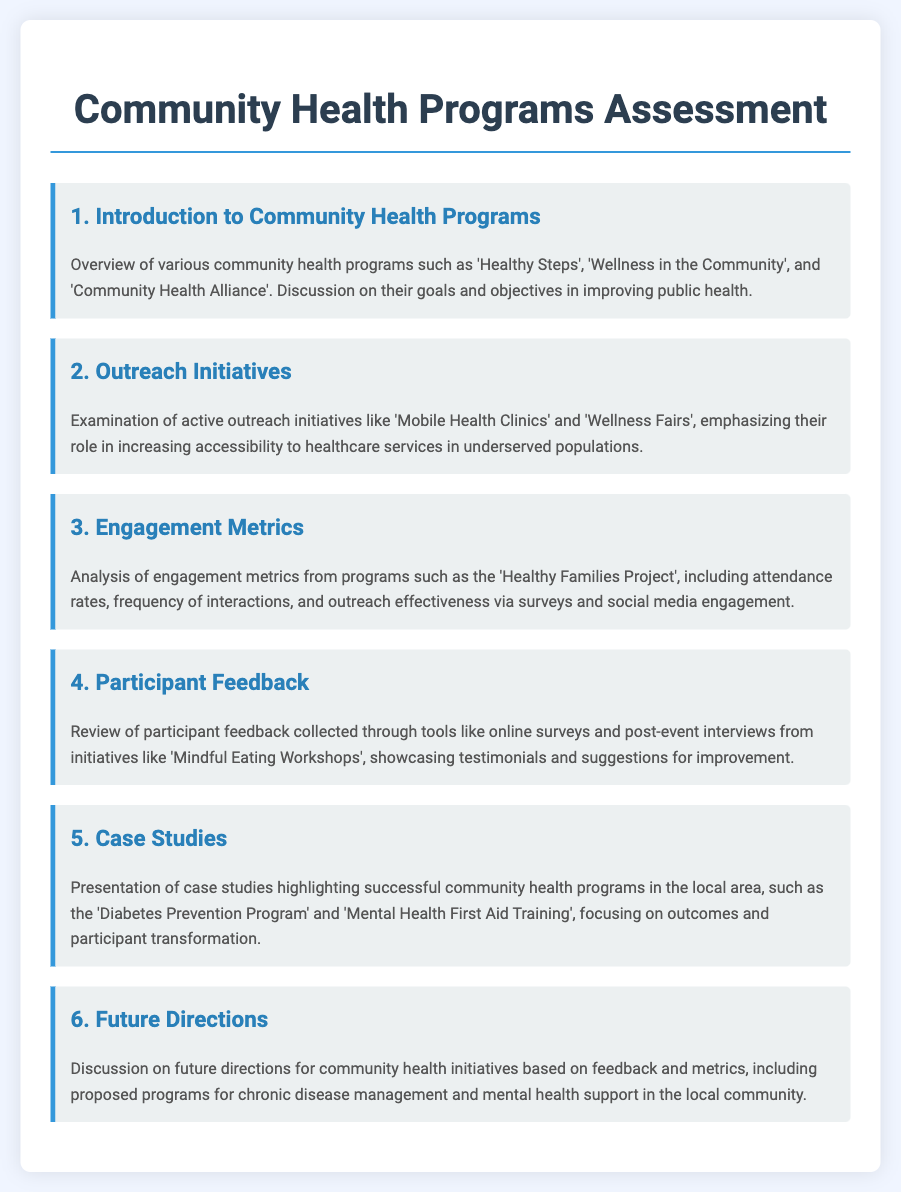what is the title of the document? The title of the document is provided in the header section, indicating the main topic discussed.
Answer: Community Health Programs Assessment how many community health programs are mentioned? The introduction section lists various community health programs, specifically mentioning three programs.
Answer: three what is one of the outreach initiatives discussed? The outreach initiatives section highlights specific programs designed to increase healthcare accessibility, which are mentioned explicitly.
Answer: Mobile Health Clinics what feedback tools are mentioned in relation to participant feedback? The participant feedback section details the methods used to gather participant opinions about the initiatives, indicating the tools utilized.
Answer: online surveys which initiative focuses on diabetes prevention? The case studies section points to specific programs that focus on health issues, naming a program dedicated to preventing diabetes.
Answer: Diabetes Prevention Program what is one proposed future direction for community health initiatives? The future directions section suggests areas for development based on community needs and feedback, mentioning specific health concerns.
Answer: chronic disease management 